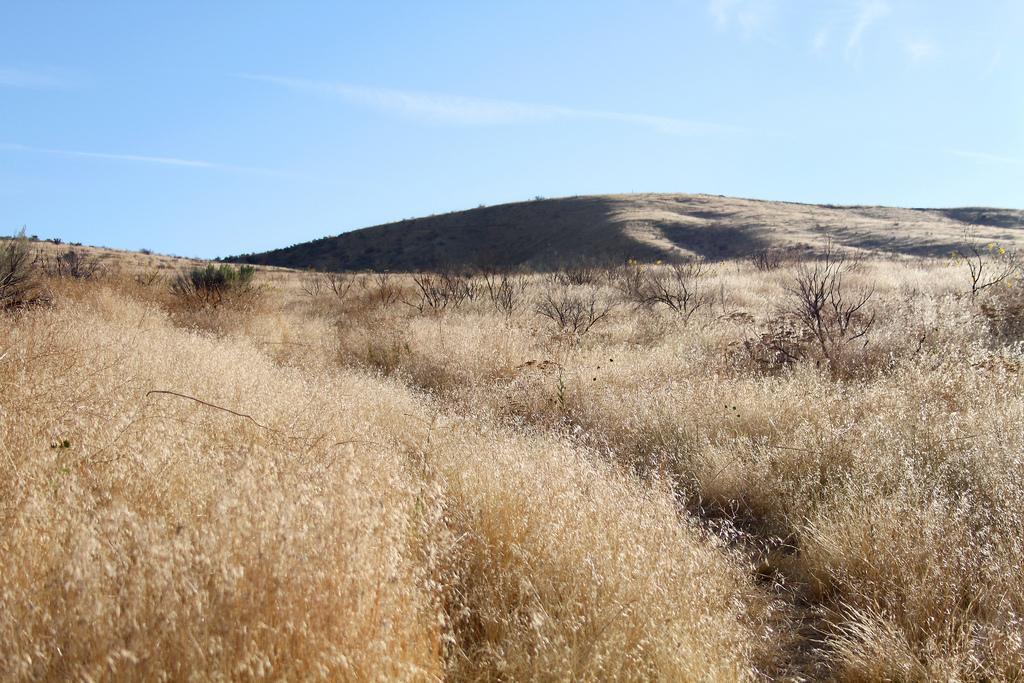Can you describe this image briefly? In this image we can see dried grass and plants on the hills. At the top we can see the sky. 